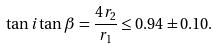Convert formula to latex. <formula><loc_0><loc_0><loc_500><loc_500>\tan i \tan \beta = \frac { 4 r _ { 2 } } { r _ { 1 } } \leq 0 . 9 4 \pm 0 . 1 0 .</formula> 